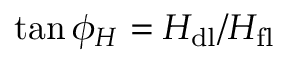<formula> <loc_0><loc_0><loc_500><loc_500>\tan { \phi _ { H } } = H _ { d l } / H _ { f l }</formula> 